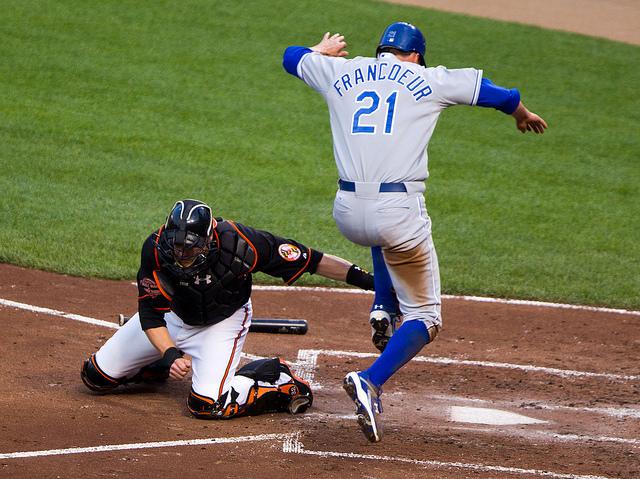Did the player touch the home plate?
Short answer required. No. Who is touching home?
Keep it brief. Francoeur. What color is the base?
Write a very short answer. White. What is the name of the player wearing number 25?
Concise answer only. Francoeur. 